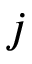Convert formula to latex. <formula><loc_0><loc_0><loc_500><loc_500>j</formula> 